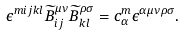Convert formula to latex. <formula><loc_0><loc_0><loc_500><loc_500>\epsilon ^ { m i j k l } \widetilde { B } ^ { \mu \nu } _ { i j } \widetilde { B } ^ { \rho \sigma } _ { k l } = c ^ { m } _ { \alpha } \epsilon ^ { \alpha \mu \nu \rho \sigma } .</formula> 